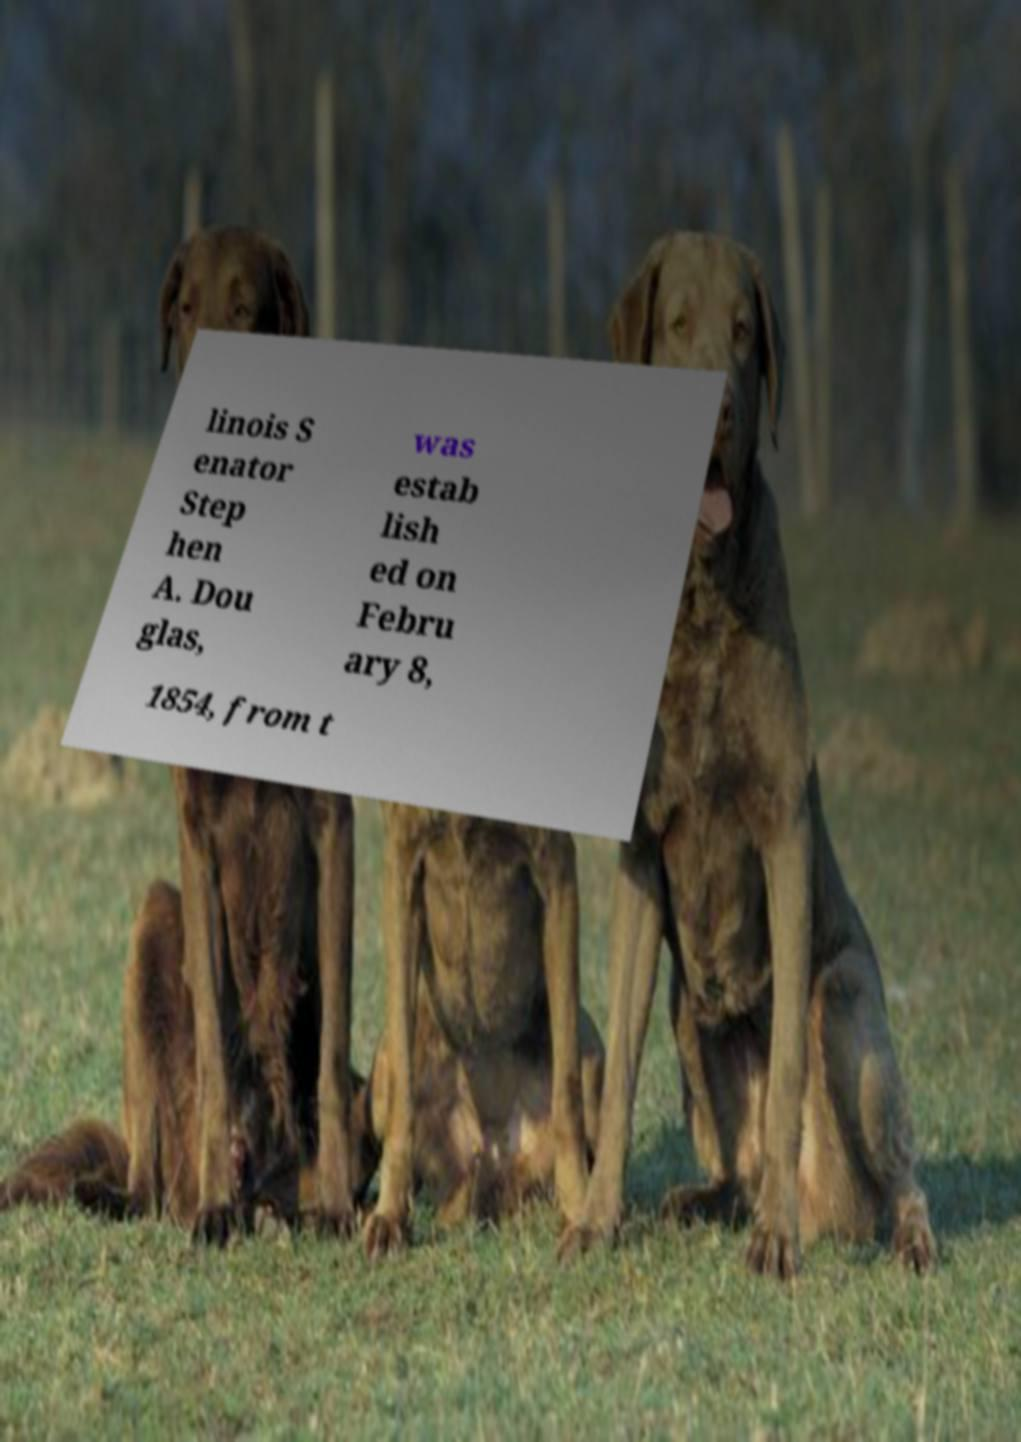There's text embedded in this image that I need extracted. Can you transcribe it verbatim? linois S enator Step hen A. Dou glas, was estab lish ed on Febru ary 8, 1854, from t 